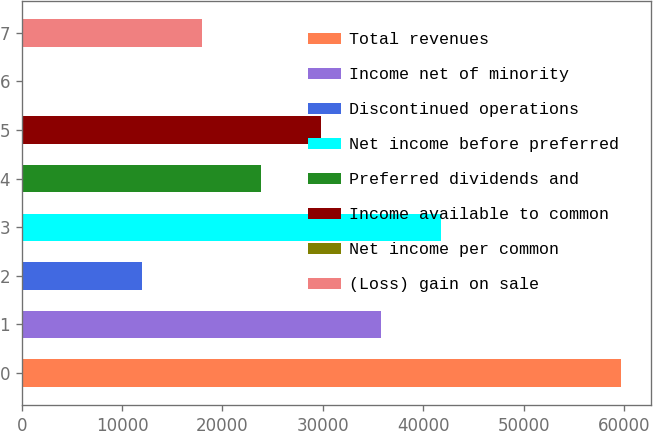Convert chart. <chart><loc_0><loc_0><loc_500><loc_500><bar_chart><fcel>Total revenues<fcel>Income net of minority<fcel>Discontinued operations<fcel>Net income before preferred<fcel>Preferred dividends and<fcel>Income available to common<fcel>Net income per common<fcel>(Loss) gain on sale<nl><fcel>59723<fcel>35834<fcel>11945<fcel>41806.2<fcel>23889.5<fcel>29861.8<fcel>0.5<fcel>17917.2<nl></chart> 